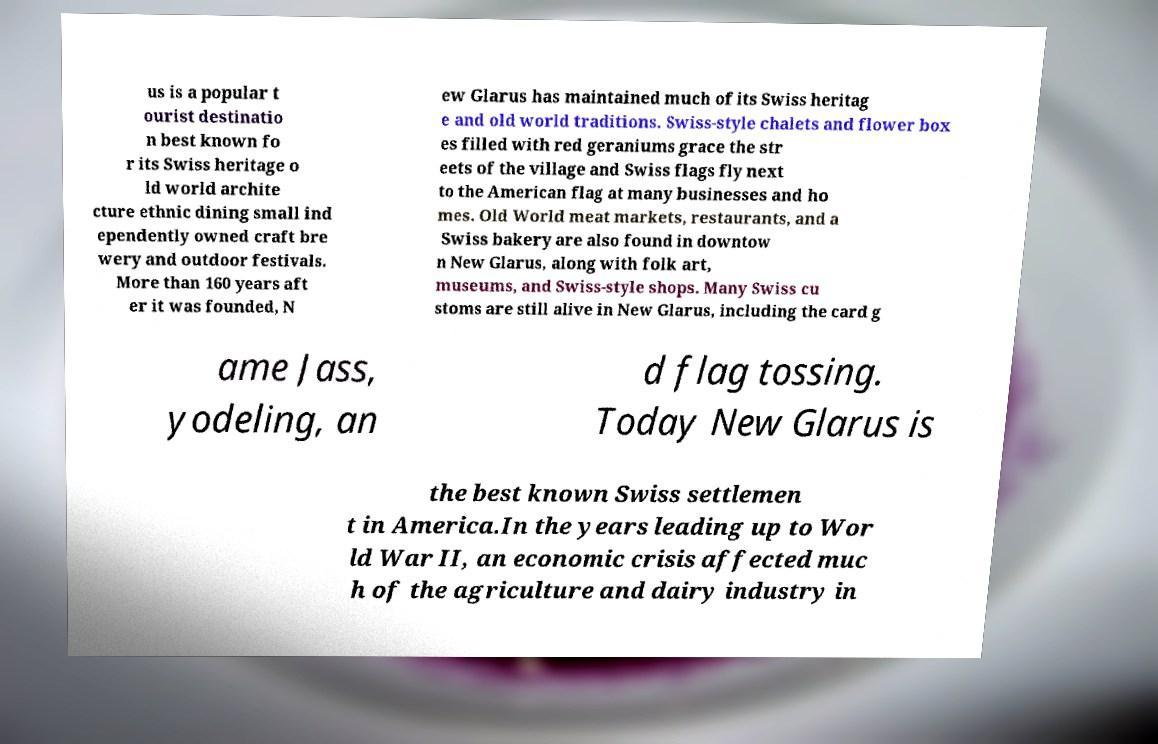Can you accurately transcribe the text from the provided image for me? us is a popular t ourist destinatio n best known fo r its Swiss heritage o ld world archite cture ethnic dining small ind ependently owned craft bre wery and outdoor festivals. More than 160 years aft er it was founded, N ew Glarus has maintained much of its Swiss heritag e and old world traditions. Swiss-style chalets and flower box es filled with red geraniums grace the str eets of the village and Swiss flags fly next to the American flag at many businesses and ho mes. Old World meat markets, restaurants, and a Swiss bakery are also found in downtow n New Glarus, along with folk art, museums, and Swiss-style shops. Many Swiss cu stoms are still alive in New Glarus, including the card g ame Jass, yodeling, an d flag tossing. Today New Glarus is the best known Swiss settlemen t in America.In the years leading up to Wor ld War II, an economic crisis affected muc h of the agriculture and dairy industry in 